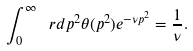<formula> <loc_0><loc_0><loc_500><loc_500>\int _ { 0 } ^ { \infty } \ r d p ^ { 2 } \theta ( p ^ { 2 } ) e ^ { - \nu p ^ { 2 } } = \frac { 1 } { \nu } .</formula> 